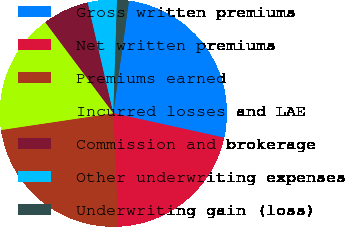Convert chart. <chart><loc_0><loc_0><loc_500><loc_500><pie_chart><fcel>Gross written premiums<fcel>Net written premiums<fcel>Premiums earned<fcel>Incurred losses and LAE<fcel>Commission and brokerage<fcel>Other underwriting expenses<fcel>Underwriting gain (loss)<nl><fcel>26.27%<fcel>20.86%<fcel>23.32%<fcel>17.14%<fcel>6.6%<fcel>4.14%<fcel>1.68%<nl></chart> 